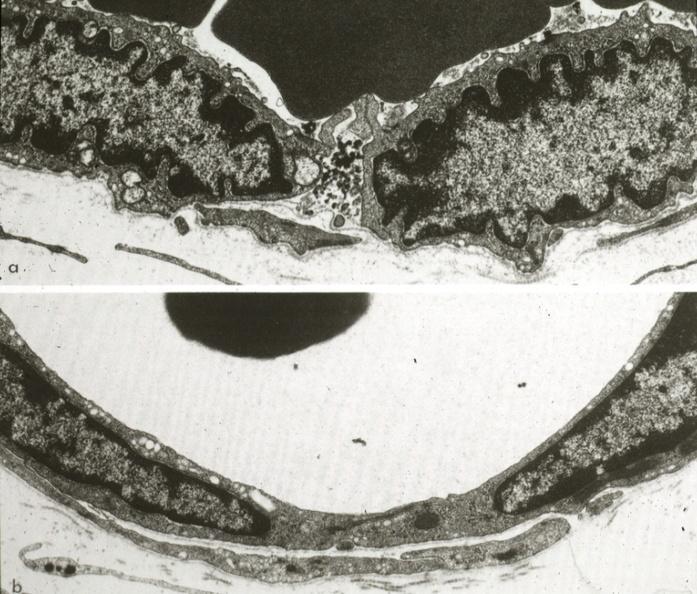what is present?
Answer the question using a single word or phrase. Cardiovascular 